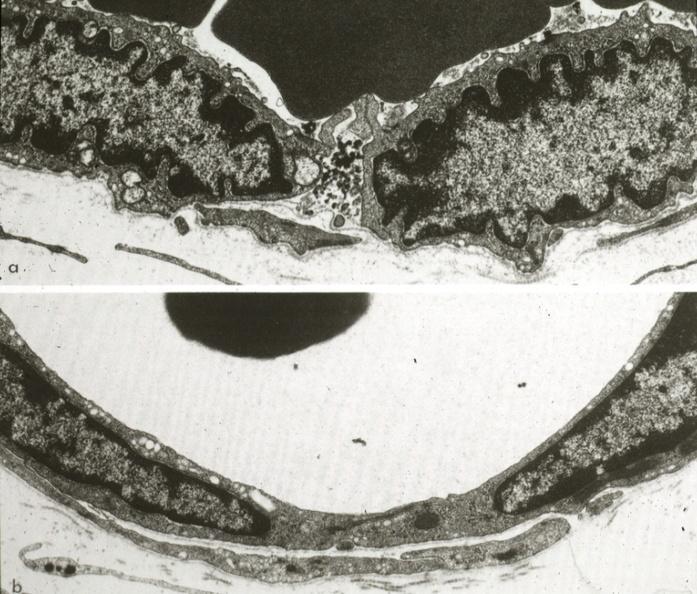what is present?
Answer the question using a single word or phrase. Cardiovascular 